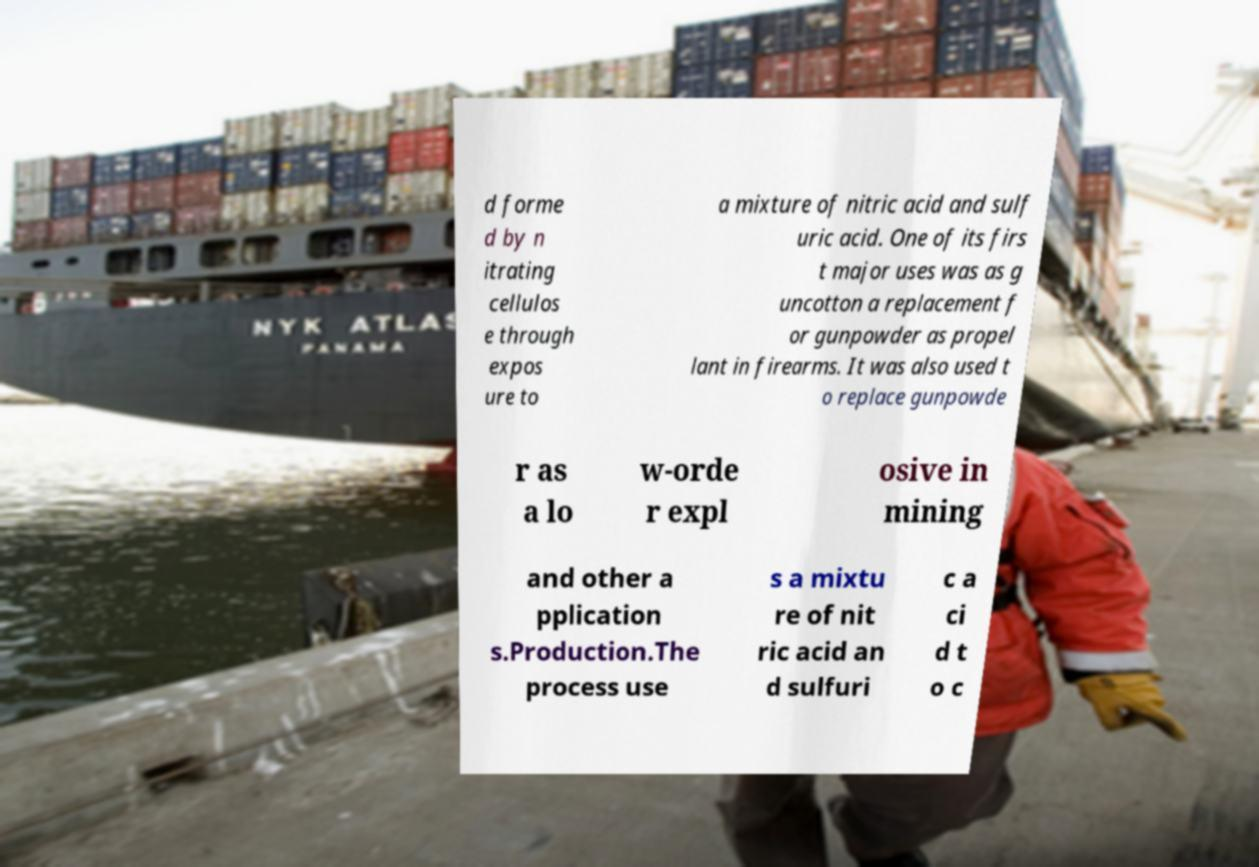Could you assist in decoding the text presented in this image and type it out clearly? d forme d by n itrating cellulos e through expos ure to a mixture of nitric acid and sulf uric acid. One of its firs t major uses was as g uncotton a replacement f or gunpowder as propel lant in firearms. It was also used t o replace gunpowde r as a lo w-orde r expl osive in mining and other a pplication s.Production.The process use s a mixtu re of nit ric acid an d sulfuri c a ci d t o c 